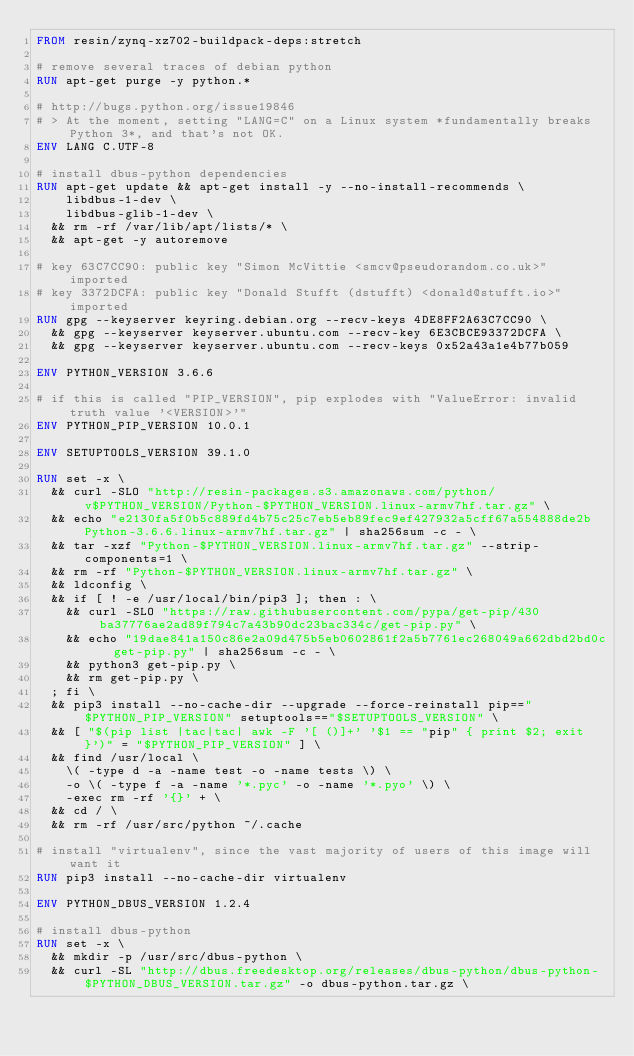Convert code to text. <code><loc_0><loc_0><loc_500><loc_500><_Dockerfile_>FROM resin/zynq-xz702-buildpack-deps:stretch

# remove several traces of debian python
RUN apt-get purge -y python.*

# http://bugs.python.org/issue19846
# > At the moment, setting "LANG=C" on a Linux system *fundamentally breaks Python 3*, and that's not OK.
ENV LANG C.UTF-8

# install dbus-python dependencies 
RUN apt-get update && apt-get install -y --no-install-recommends \
		libdbus-1-dev \
		libdbus-glib-1-dev \
	&& rm -rf /var/lib/apt/lists/* \
	&& apt-get -y autoremove

# key 63C7CC90: public key "Simon McVittie <smcv@pseudorandom.co.uk>" imported
# key 3372DCFA: public key "Donald Stufft (dstufft) <donald@stufft.io>" imported
RUN gpg --keyserver keyring.debian.org --recv-keys 4DE8FF2A63C7CC90 \
	&& gpg --keyserver keyserver.ubuntu.com --recv-key 6E3CBCE93372DCFA \
	&& gpg --keyserver keyserver.ubuntu.com --recv-keys 0x52a43a1e4b77b059

ENV PYTHON_VERSION 3.6.6

# if this is called "PIP_VERSION", pip explodes with "ValueError: invalid truth value '<VERSION>'"
ENV PYTHON_PIP_VERSION 10.0.1

ENV SETUPTOOLS_VERSION 39.1.0

RUN set -x \
	&& curl -SLO "http://resin-packages.s3.amazonaws.com/python/v$PYTHON_VERSION/Python-$PYTHON_VERSION.linux-armv7hf.tar.gz" \
	&& echo "e2130fa5f0b5c889fd4b75c25c7eb5eb89fec9ef427932a5cff67a554888de2b  Python-3.6.6.linux-armv7hf.tar.gz" | sha256sum -c - \
	&& tar -xzf "Python-$PYTHON_VERSION.linux-armv7hf.tar.gz" --strip-components=1 \
	&& rm -rf "Python-$PYTHON_VERSION.linux-armv7hf.tar.gz" \
	&& ldconfig \
	&& if [ ! -e /usr/local/bin/pip3 ]; then : \
		&& curl -SLO "https://raw.githubusercontent.com/pypa/get-pip/430ba37776ae2ad89f794c7a43b90dc23bac334c/get-pip.py" \
		&& echo "19dae841a150c86e2a09d475b5eb0602861f2a5b7761ec268049a662dbd2bd0c  get-pip.py" | sha256sum -c - \
		&& python3 get-pip.py \
		&& rm get-pip.py \
	; fi \
	&& pip3 install --no-cache-dir --upgrade --force-reinstall pip=="$PYTHON_PIP_VERSION" setuptools=="$SETUPTOOLS_VERSION" \
	&& [ "$(pip list |tac|tac| awk -F '[ ()]+' '$1 == "pip" { print $2; exit }')" = "$PYTHON_PIP_VERSION" ] \
	&& find /usr/local \
		\( -type d -a -name test -o -name tests \) \
		-o \( -type f -a -name '*.pyc' -o -name '*.pyo' \) \
		-exec rm -rf '{}' + \
	&& cd / \
	&& rm -rf /usr/src/python ~/.cache

# install "virtualenv", since the vast majority of users of this image will want it
RUN pip3 install --no-cache-dir virtualenv

ENV PYTHON_DBUS_VERSION 1.2.4

# install dbus-python
RUN set -x \
	&& mkdir -p /usr/src/dbus-python \
	&& curl -SL "http://dbus.freedesktop.org/releases/dbus-python/dbus-python-$PYTHON_DBUS_VERSION.tar.gz" -o dbus-python.tar.gz \</code> 